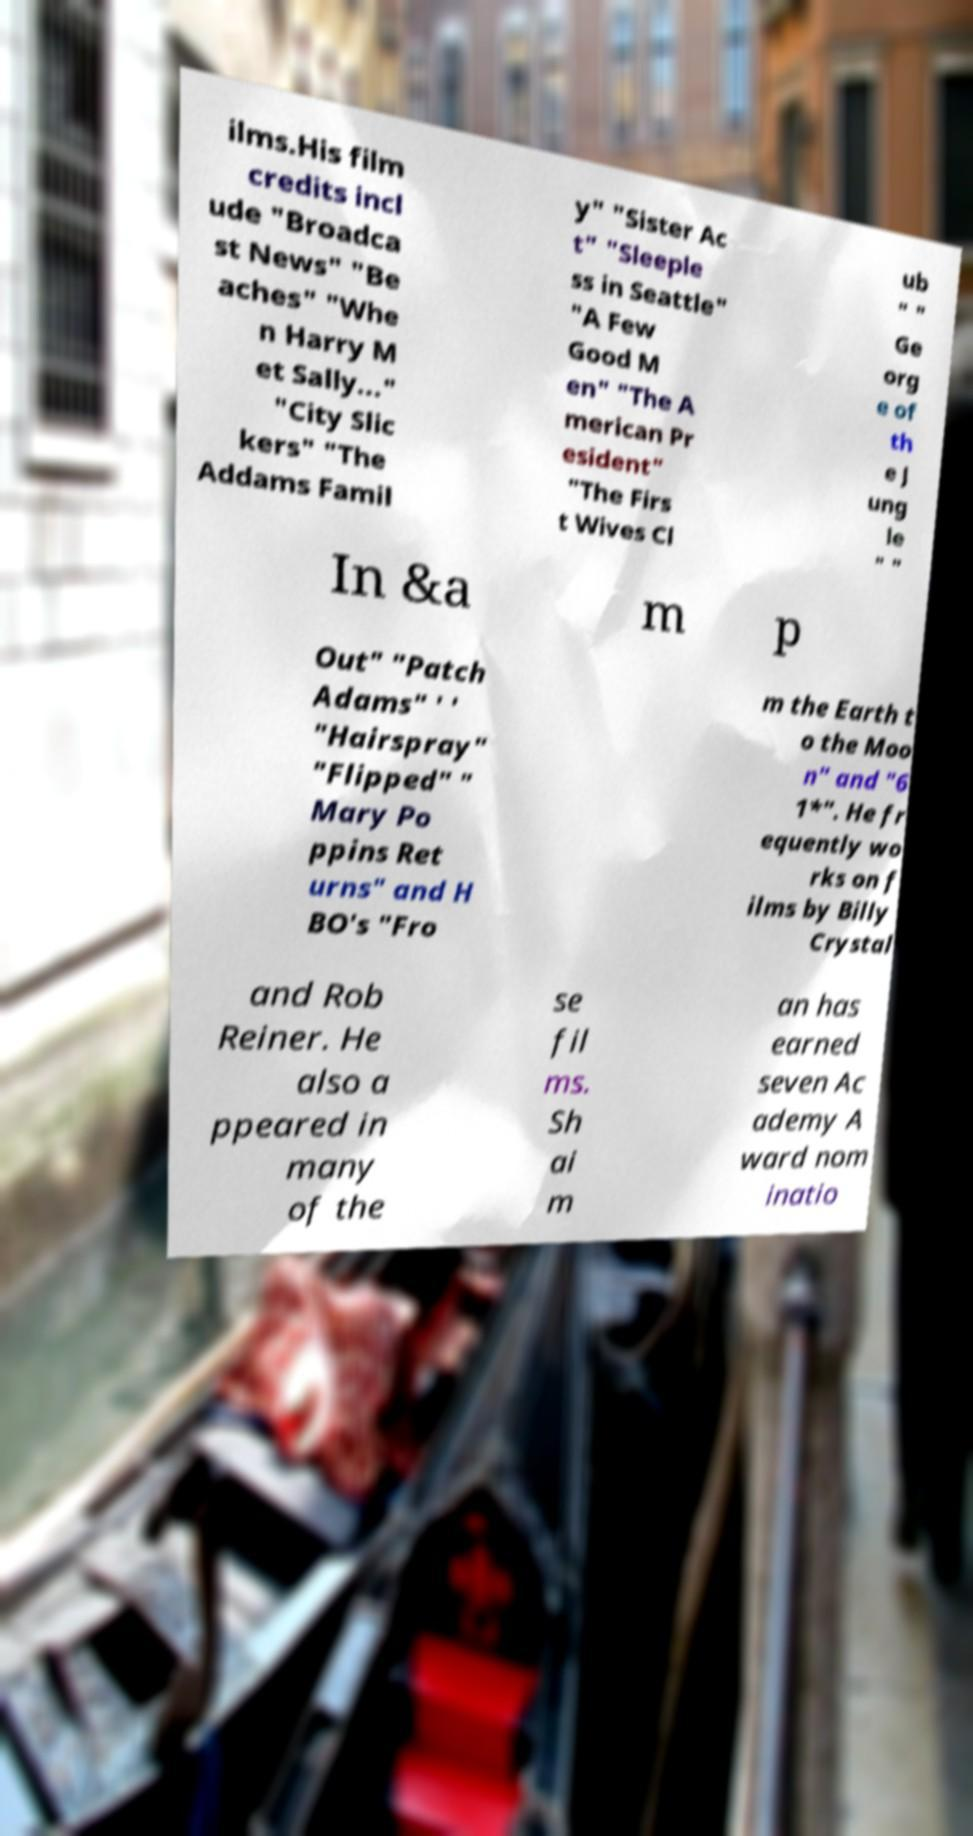Could you extract and type out the text from this image? ilms.His film credits incl ude "Broadca st News" "Be aches" "Whe n Harry M et Sally..." "City Slic kers" "The Addams Famil y" "Sister Ac t" "Sleeple ss in Seattle" "A Few Good M en" "The A merican Pr esident" "The Firs t Wives Cl ub " " Ge org e of th e J ung le " " In &a m p Out" "Patch Adams" ' ' "Hairspray" "Flipped" " Mary Po ppins Ret urns" and H BO's "Fro m the Earth t o the Moo n" and "6 1*". He fr equently wo rks on f ilms by Billy Crystal and Rob Reiner. He also a ppeared in many of the se fil ms. Sh ai m an has earned seven Ac ademy A ward nom inatio 